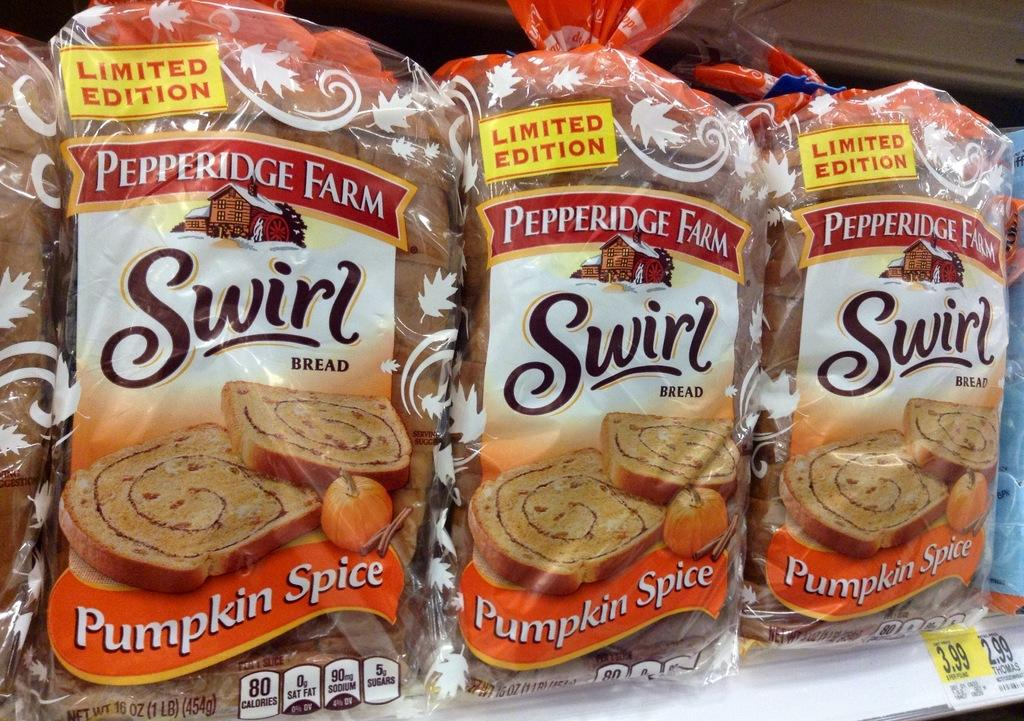What type of items can be seen in the image? There are food packets and stickers in the image. What is written on the food packets? Something is written on the food packets. What is written on the stickers? Something is written on the stickers. How does the car affect the stomach in the image? There is no car present in the image, so it cannot affect the stomach. 